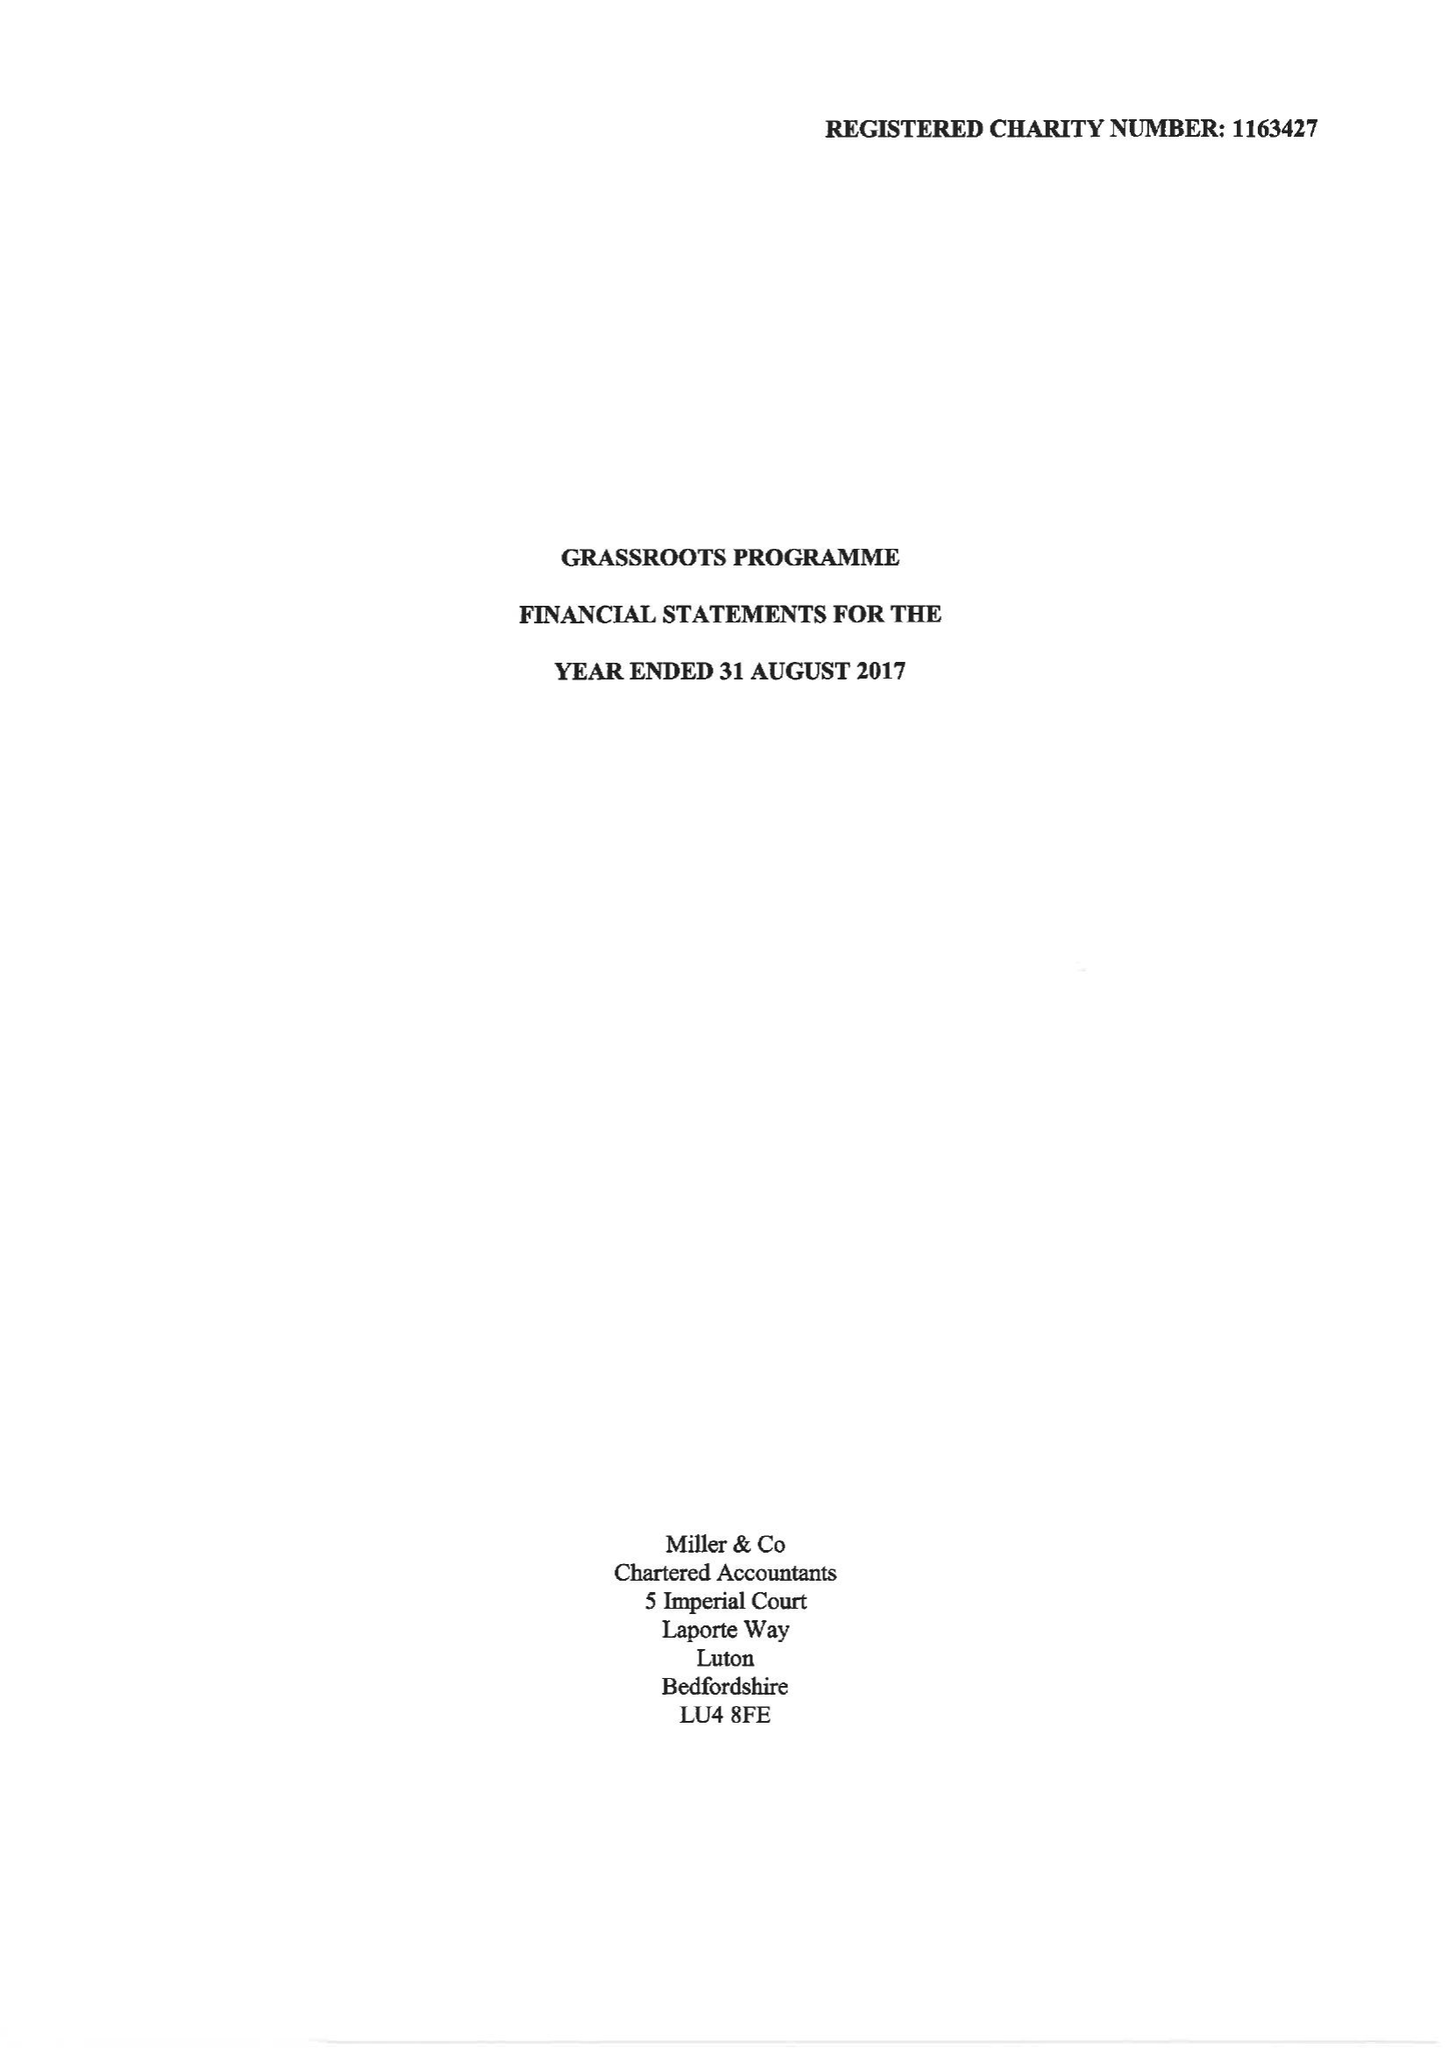What is the value for the spending_annually_in_british_pounds?
Answer the question using a single word or phrase. 160474.00 